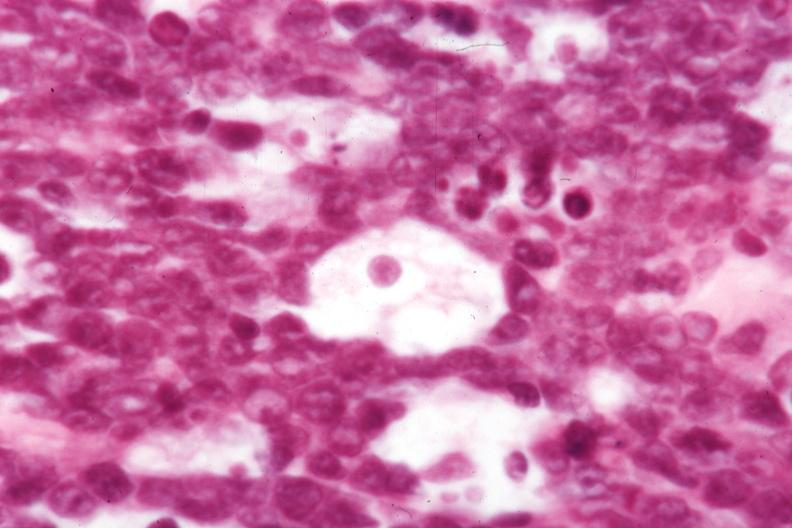s burkitts lymphoma present?
Answer the question using a single word or phrase. Yes 